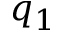<formula> <loc_0><loc_0><loc_500><loc_500>q _ { 1 }</formula> 